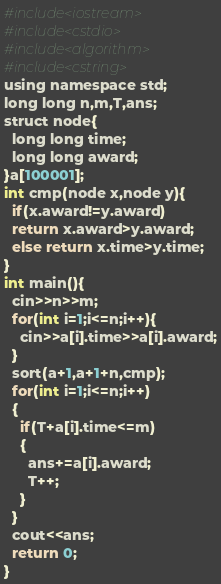Convert code to text. <code><loc_0><loc_0><loc_500><loc_500><_Python_>#include<iostream>
#include<cstdio>
#include<algorithm>
#include<cstring>
using namespace std;
long long n,m,T,ans;
struct node{
  long long time;
  long long award;
}a[100001];
int cmp(node x,node y){
  if(x.award!=y.award)	
  return x.award>y.award;
  else return x.time>y.time; 
}
int main(){
  cin>>n>>m;
  for(int i=1;i<=n;i++){
    cin>>a[i].time>>a[i].award;
  }
  sort(a+1,a+1+n,cmp);
  for(int i=1;i<=n;i++)
  {
    if(T+a[i].time<=m)
    {
      ans+=a[i].award;
      T++;
    }
  }
  cout<<ans;
  return 0;
}</code> 